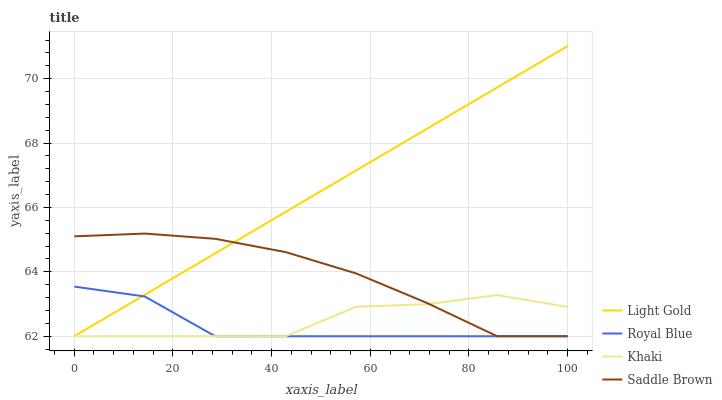Does Royal Blue have the minimum area under the curve?
Answer yes or no. Yes. Does Light Gold have the maximum area under the curve?
Answer yes or no. Yes. Does Khaki have the minimum area under the curve?
Answer yes or no. No. Does Khaki have the maximum area under the curve?
Answer yes or no. No. Is Light Gold the smoothest?
Answer yes or no. Yes. Is Khaki the roughest?
Answer yes or no. Yes. Is Khaki the smoothest?
Answer yes or no. No. Is Light Gold the roughest?
Answer yes or no. No. Does Royal Blue have the lowest value?
Answer yes or no. Yes. Does Light Gold have the highest value?
Answer yes or no. Yes. Does Khaki have the highest value?
Answer yes or no. No. Does Saddle Brown intersect Light Gold?
Answer yes or no. Yes. Is Saddle Brown less than Light Gold?
Answer yes or no. No. Is Saddle Brown greater than Light Gold?
Answer yes or no. No. 